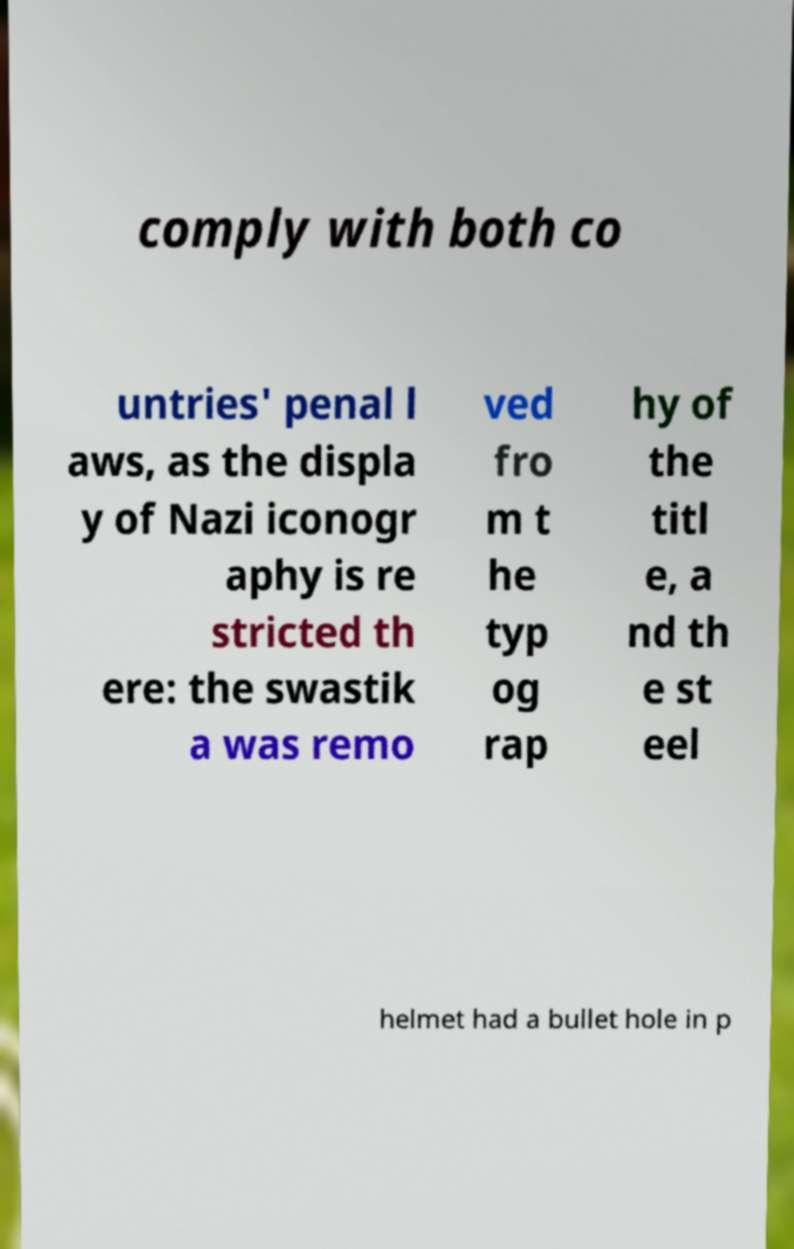Can you accurately transcribe the text from the provided image for me? comply with both co untries' penal l aws, as the displa y of Nazi iconogr aphy is re stricted th ere: the swastik a was remo ved fro m t he typ og rap hy of the titl e, a nd th e st eel helmet had a bullet hole in p 